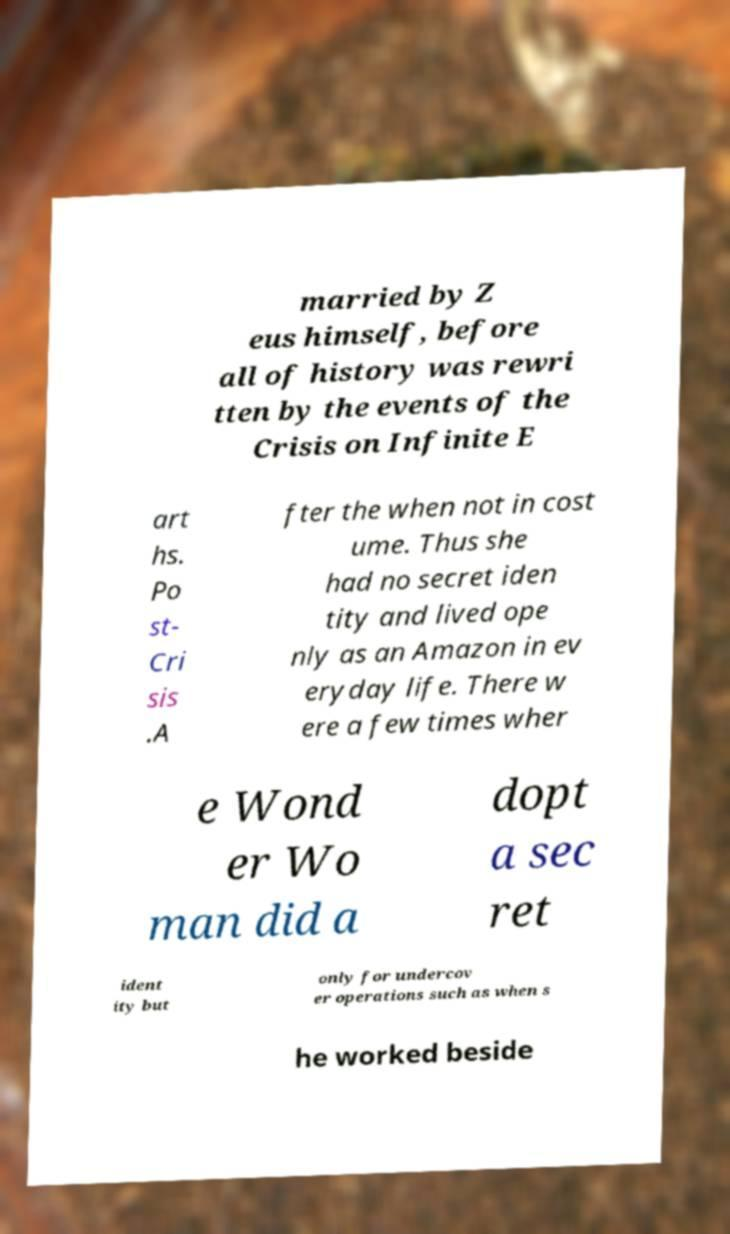What messages or text are displayed in this image? I need them in a readable, typed format. married by Z eus himself, before all of history was rewri tten by the events of the Crisis on Infinite E art hs. Po st- Cri sis .A fter the when not in cost ume. Thus she had no secret iden tity and lived ope nly as an Amazon in ev eryday life. There w ere a few times wher e Wond er Wo man did a dopt a sec ret ident ity but only for undercov er operations such as when s he worked beside 